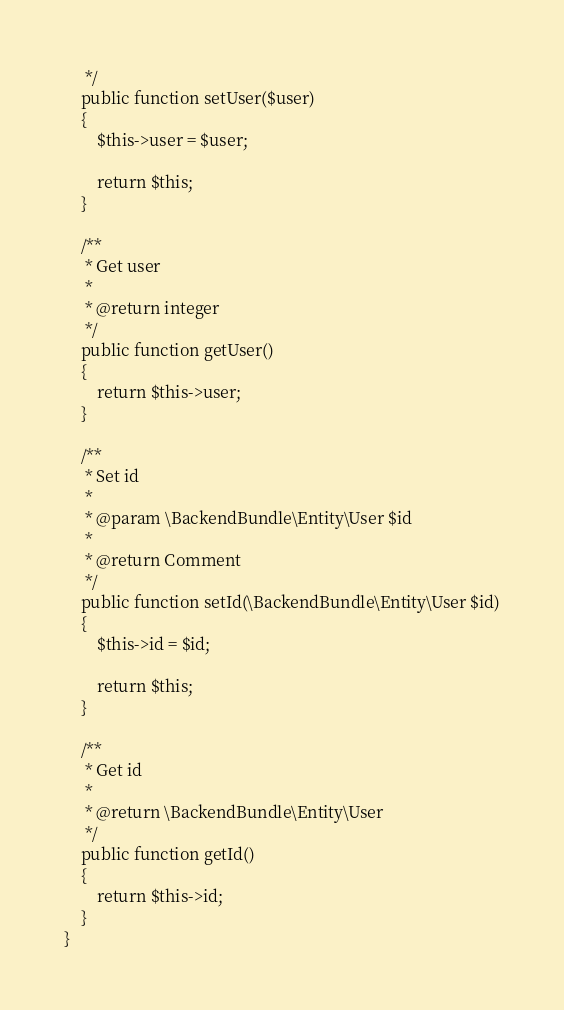Convert code to text. <code><loc_0><loc_0><loc_500><loc_500><_PHP_>     */
    public function setUser($user)
    {
        $this->user = $user;

        return $this;
    }

    /**
     * Get user
     *
     * @return integer
     */
    public function getUser()
    {
        return $this->user;
    }

    /**
     * Set id
     *
     * @param \BackendBundle\Entity\User $id
     *
     * @return Comment
     */
    public function setId(\BackendBundle\Entity\User $id)
    {
        $this->id = $id;

        return $this;
    }

    /**
     * Get id
     *
     * @return \BackendBundle\Entity\User
     */
    public function getId()
    {
        return $this->id;
    }
}
</code> 